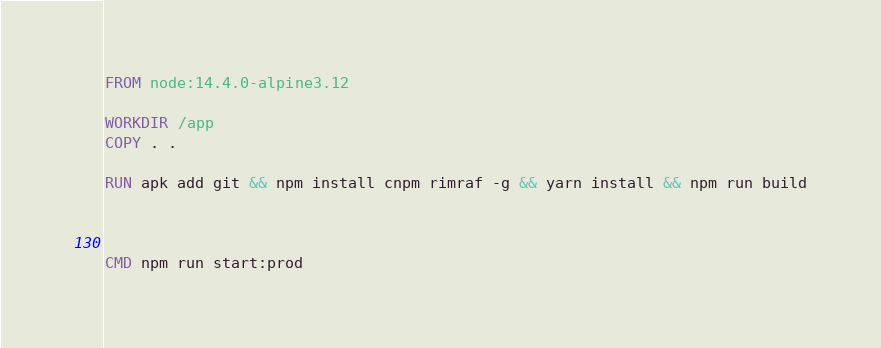<code> <loc_0><loc_0><loc_500><loc_500><_Dockerfile_>FROM node:14.4.0-alpine3.12

WORKDIR /app
COPY . .

RUN apk add git && npm install cnpm rimraf -g && yarn install && npm run build



CMD npm run start:prod</code> 